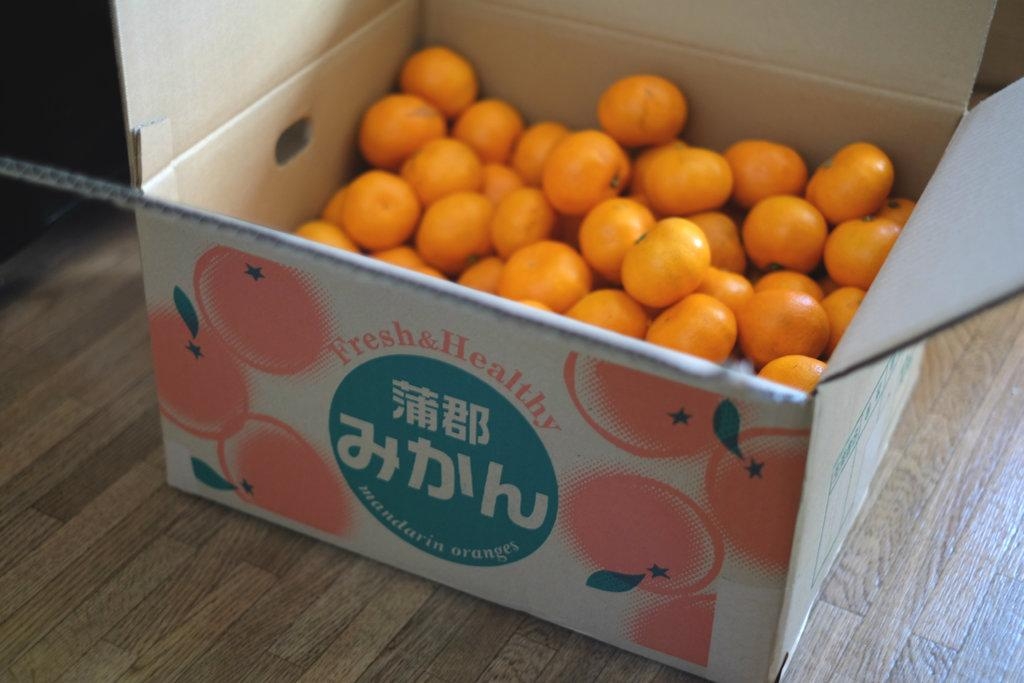What is the main object in the image? There is a cardboard box in the image. What is inside the cardboard box? The box contains oranges. Are there any visual elements related to the contents of the box? Yes, there are images of oranges on the box. Is there any text on the box? Yes, there is text on the box. What type of news can be seen on the cactus in the image? There is no cactus present in the image, and therefore no news can be seen on it. 